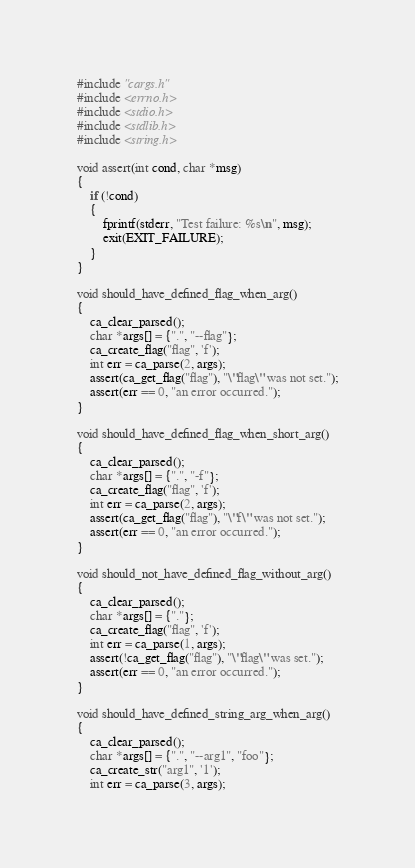Convert code to text. <code><loc_0><loc_0><loc_500><loc_500><_C_>#include "cargs.h"
#include <errno.h>
#include <stdio.h>
#include <stdlib.h>
#include <string.h>

void assert(int cond, char *msg)
{
    if (!cond)
    {
        fprintf(stderr, "Test failure: %s\n", msg);
        exit(EXIT_FAILURE);
    }
}

void should_have_defined_flag_when_arg()
{
    ca_clear_parsed();
    char *args[] = {".", "--flag"};
    ca_create_flag("flag", 'f');
    int err = ca_parse(2, args);
    assert(ca_get_flag("flag"), "\"flag\" was not set.");
    assert(err == 0, "an error occurred.");
}

void should_have_defined_flag_when_short_arg()
{
    ca_clear_parsed();
    char *args[] = {".", "-f"};
    ca_create_flag("flag", 'f');
    int err = ca_parse(2, args);
    assert(ca_get_flag("flag"), "\"f\" was not set.");
    assert(err == 0, "an error occurred.");
}

void should_not_have_defined_flag_without_arg()
{
    ca_clear_parsed();
    char *args[] = {"."};
    ca_create_flag("flag", 'f');
    int err = ca_parse(1, args);
    assert(!ca_get_flag("flag"), "\"flag\" was set.");
    assert(err == 0, "an error occurred.");
}

void should_have_defined_string_arg_when_arg()
{
    ca_clear_parsed();
    char *args[] = {".", "--arg1", "foo"};
    ca_create_str("arg1", '1');
    int err = ca_parse(3, args);</code> 